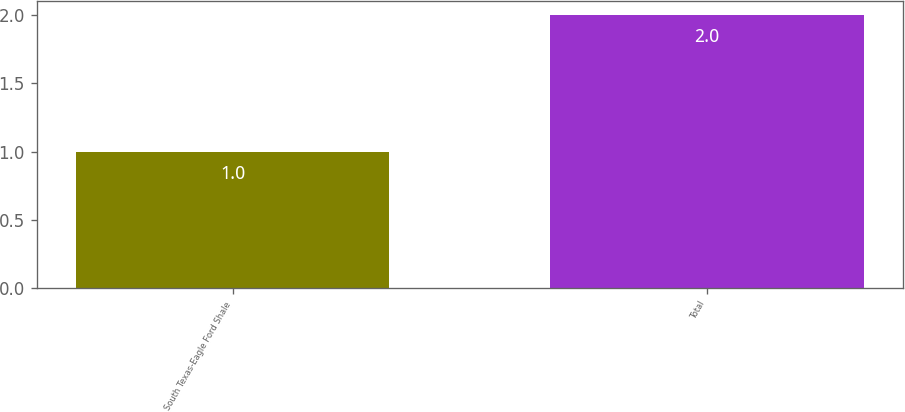Convert chart to OTSL. <chart><loc_0><loc_0><loc_500><loc_500><bar_chart><fcel>South Texas-Eagle Ford Shale<fcel>Total<nl><fcel>1<fcel>2<nl></chart> 